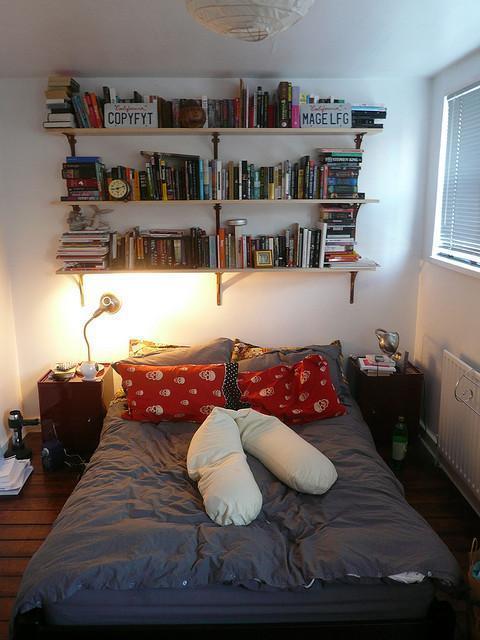How many license plates are on the shelves?
Give a very brief answer. 2. How many beds are visible?
Give a very brief answer. 1. 